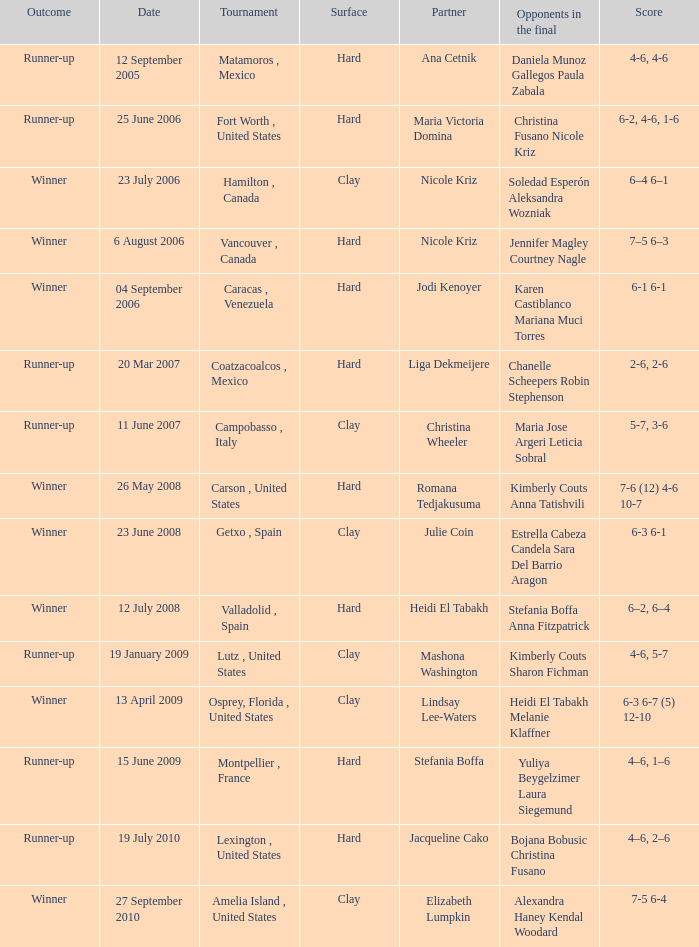What was the date for the match where Tweedie-Yates' partner was jodi kenoyer? 04 September 2006. 